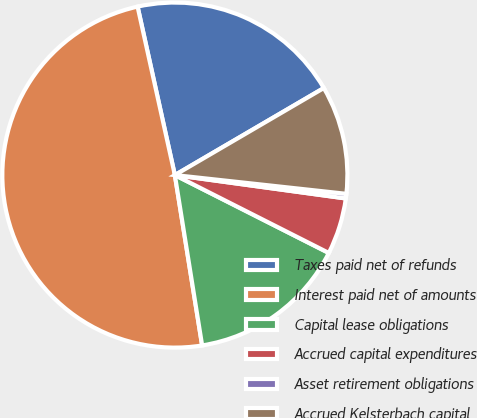<chart> <loc_0><loc_0><loc_500><loc_500><pie_chart><fcel>Taxes paid net of refunds<fcel>Interest paid net of amounts<fcel>Capital lease obligations<fcel>Accrued capital expenditures<fcel>Asset retirement obligations<fcel>Accrued Kelsterbach capital<nl><fcel>20.05%<fcel>49.06%<fcel>15.02%<fcel>5.29%<fcel>0.43%<fcel>10.15%<nl></chart> 